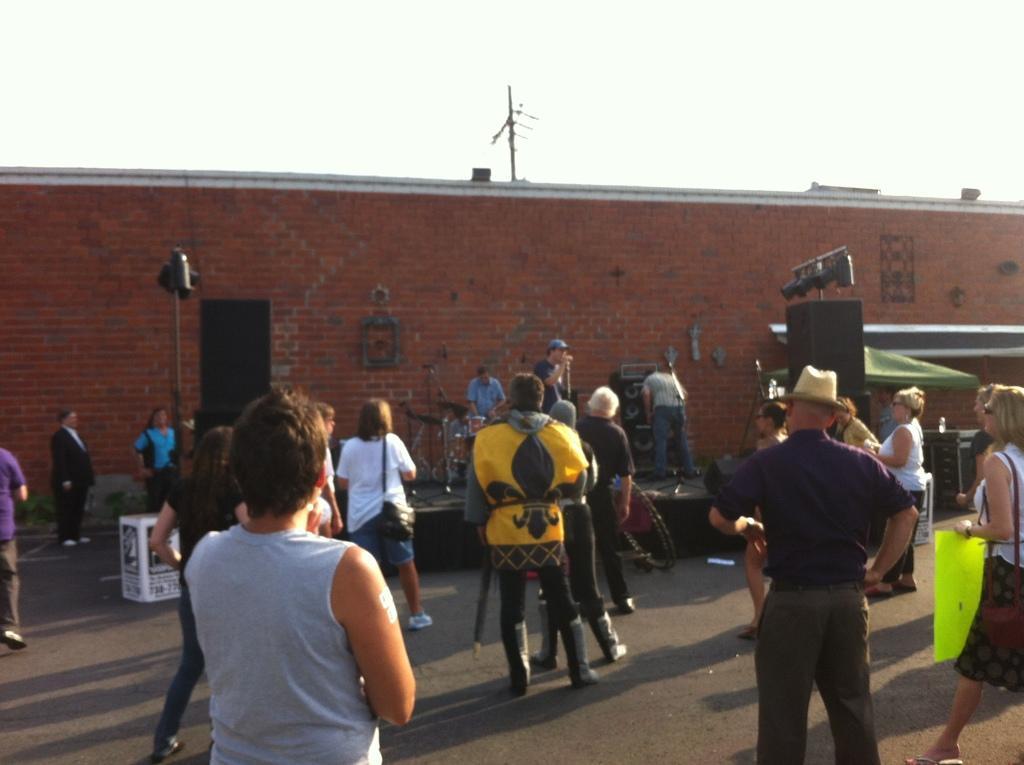Describe this image in one or two sentences. In this image people are standing on the road. In front of them people are playing the music on the stage. Beside the stage there are speakers. At the background there is a wall. On the right side of the image there is a table and on top of it there is a bottle. 